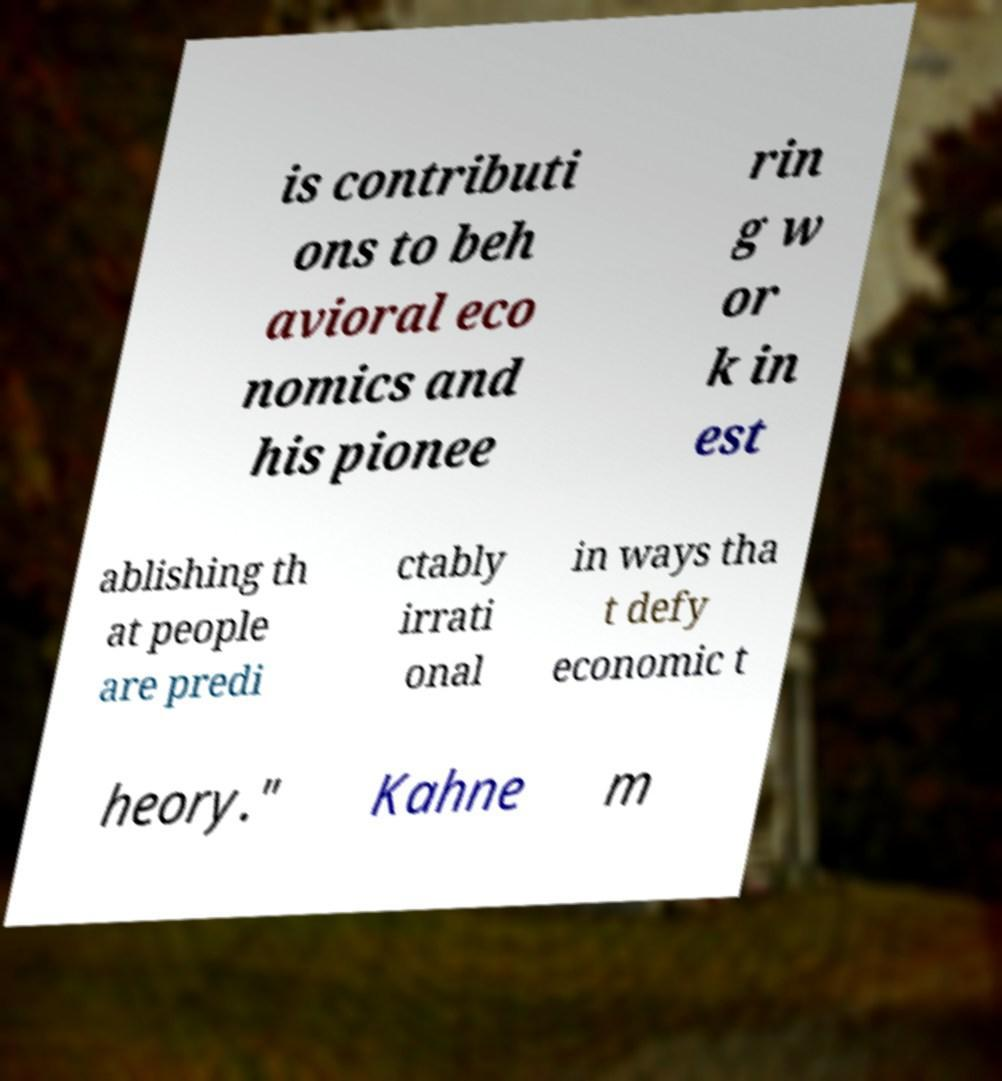Can you read and provide the text displayed in the image?This photo seems to have some interesting text. Can you extract and type it out for me? is contributi ons to beh avioral eco nomics and his pionee rin g w or k in est ablishing th at people are predi ctably irrati onal in ways tha t defy economic t heory." Kahne m 